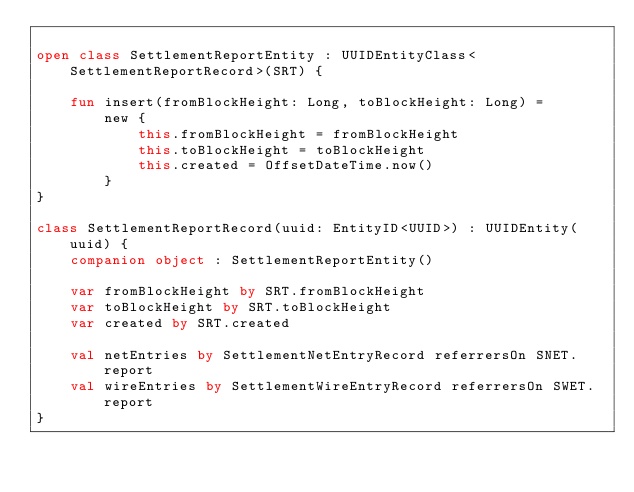Convert code to text. <code><loc_0><loc_0><loc_500><loc_500><_Kotlin_>
open class SettlementReportEntity : UUIDEntityClass<SettlementReportRecord>(SRT) {

    fun insert(fromBlockHeight: Long, toBlockHeight: Long) =
        new {
            this.fromBlockHeight = fromBlockHeight
            this.toBlockHeight = toBlockHeight
            this.created = OffsetDateTime.now()
        }
}

class SettlementReportRecord(uuid: EntityID<UUID>) : UUIDEntity(uuid) {
    companion object : SettlementReportEntity()

    var fromBlockHeight by SRT.fromBlockHeight
    var toBlockHeight by SRT.toBlockHeight
    var created by SRT.created

    val netEntries by SettlementNetEntryRecord referrersOn SNET.report
    val wireEntries by SettlementWireEntryRecord referrersOn SWET.report
}
</code> 